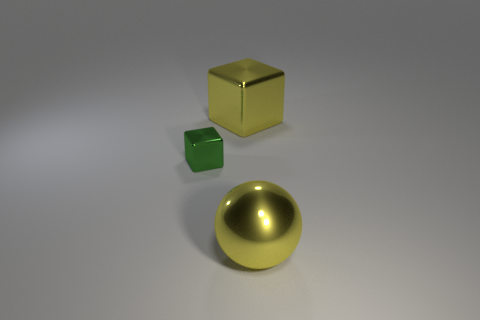What colors are present in the image? The image features objects with colors including gold, green, and a shade of silver or gray from the surface on which the objects rest. 